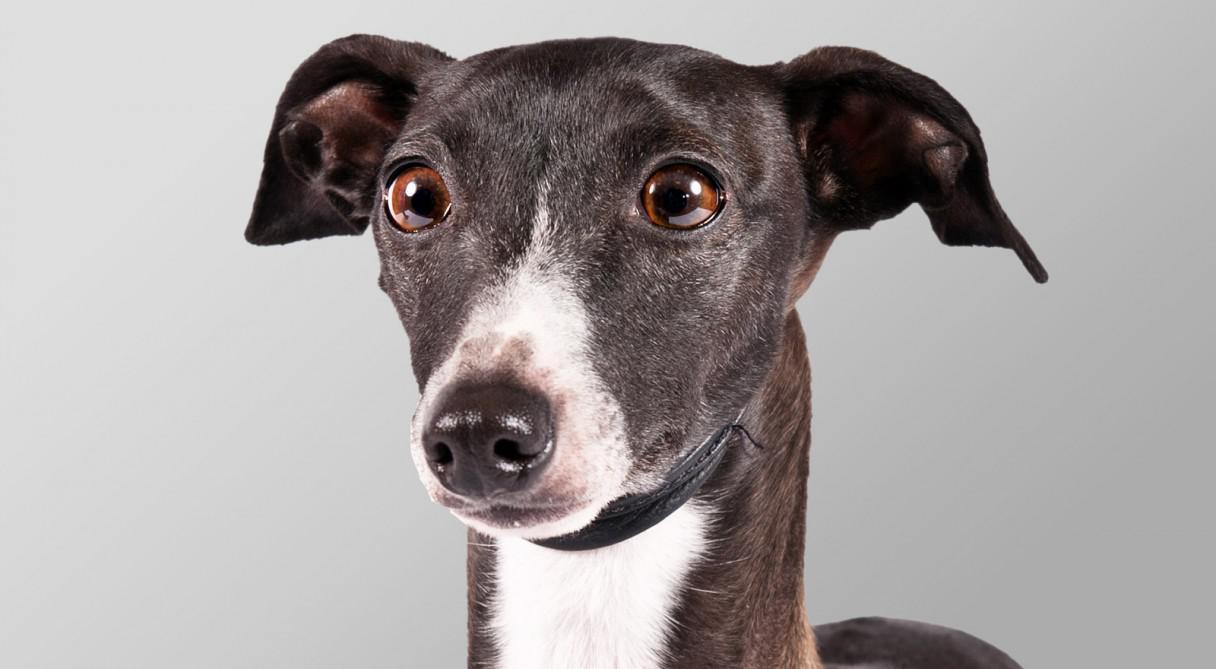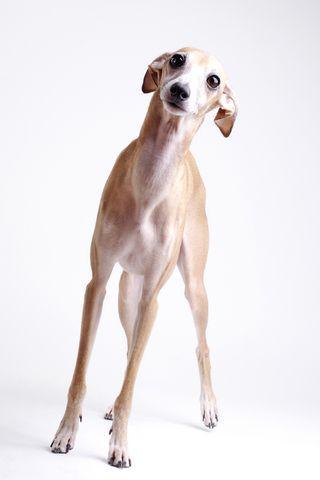The first image is the image on the left, the second image is the image on the right. Considering the images on both sides, is "The full body of a dog facing right is on the left image." valid? Answer yes or no. No. 